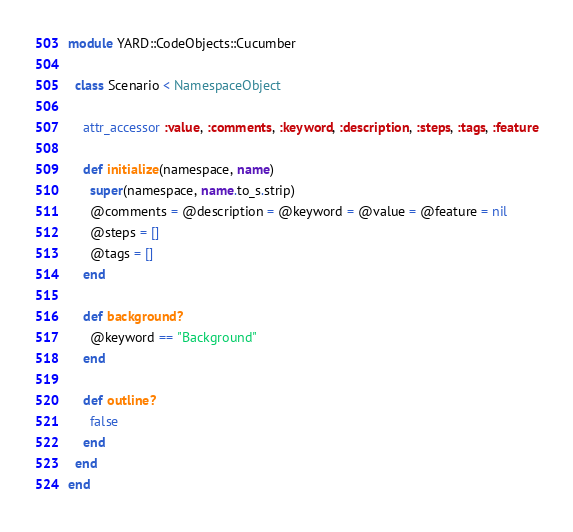<code> <loc_0><loc_0><loc_500><loc_500><_Ruby_>module YARD::CodeObjects::Cucumber

  class Scenario < NamespaceObject

    attr_accessor :value, :comments, :keyword, :description, :steps, :tags, :feature

    def initialize(namespace, name)
      super(namespace, name.to_s.strip)
      @comments = @description = @keyword = @value = @feature = nil
      @steps = []
      @tags = []
    end

    def background?
      @keyword == "Background"
    end

    def outline?
      false
    end
  end
end</code> 